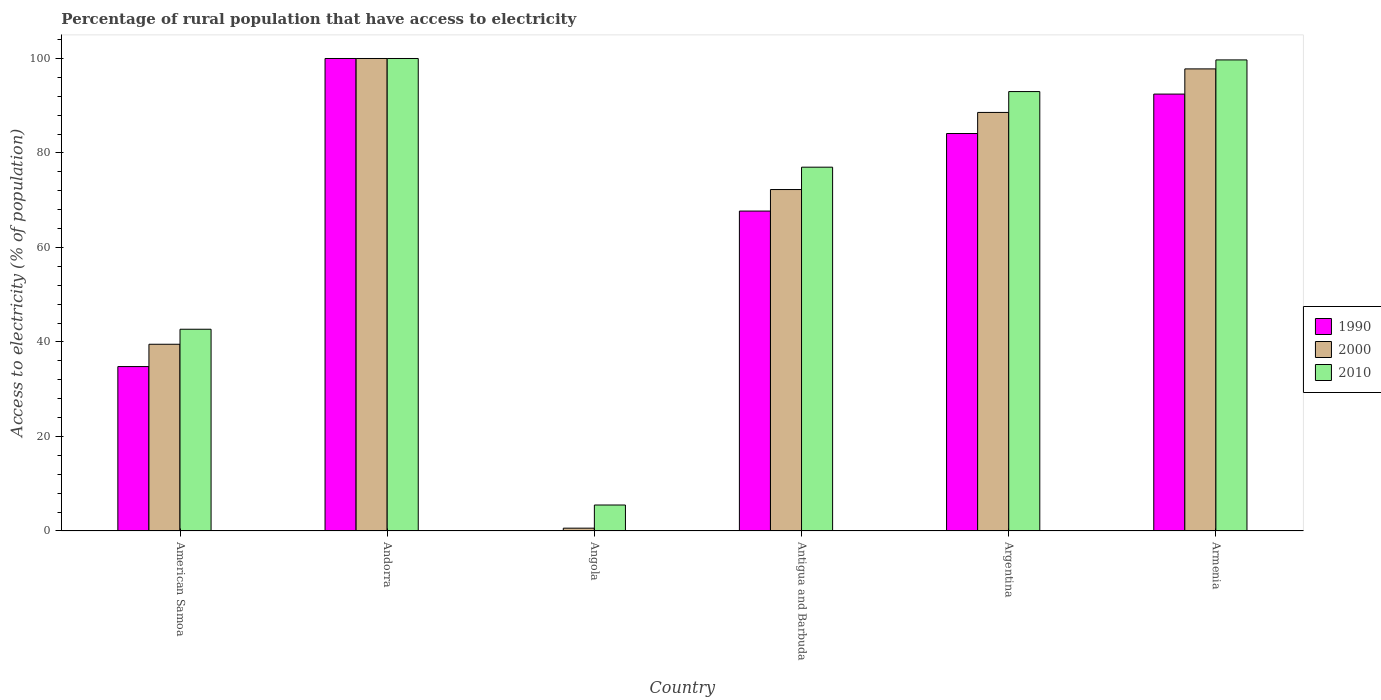How many bars are there on the 6th tick from the right?
Keep it short and to the point. 3. What is the label of the 3rd group of bars from the left?
Provide a short and direct response. Angola. In how many cases, is the number of bars for a given country not equal to the number of legend labels?
Provide a succinct answer. 0. What is the percentage of rural population that have access to electricity in 1990 in Armenia?
Ensure brevity in your answer.  92.47. In which country was the percentage of rural population that have access to electricity in 2000 maximum?
Ensure brevity in your answer.  Andorra. In which country was the percentage of rural population that have access to electricity in 2010 minimum?
Ensure brevity in your answer.  Angola. What is the total percentage of rural population that have access to electricity in 2010 in the graph?
Your answer should be compact. 417.9. What is the difference between the percentage of rural population that have access to electricity in 2000 in Antigua and Barbuda and that in Argentina?
Make the answer very short. -16.32. What is the average percentage of rural population that have access to electricity in 2010 per country?
Ensure brevity in your answer.  69.65. What is the difference between the percentage of rural population that have access to electricity of/in 2010 and percentage of rural population that have access to electricity of/in 1990 in Antigua and Barbuda?
Your answer should be very brief. 9.29. What is the ratio of the percentage of rural population that have access to electricity in 2010 in Angola to that in Argentina?
Offer a very short reply. 0.06. Is the difference between the percentage of rural population that have access to electricity in 2010 in Argentina and Armenia greater than the difference between the percentage of rural population that have access to electricity in 1990 in Argentina and Armenia?
Provide a succinct answer. Yes. What is the difference between the highest and the second highest percentage of rural population that have access to electricity in 2000?
Offer a very short reply. -9.21. What is the difference between the highest and the lowest percentage of rural population that have access to electricity in 2000?
Give a very brief answer. 99.4. Is the sum of the percentage of rural population that have access to electricity in 2000 in American Samoa and Andorra greater than the maximum percentage of rural population that have access to electricity in 2010 across all countries?
Offer a very short reply. Yes. Is it the case that in every country, the sum of the percentage of rural population that have access to electricity in 2010 and percentage of rural population that have access to electricity in 1990 is greater than the percentage of rural population that have access to electricity in 2000?
Your answer should be compact. Yes. How many countries are there in the graph?
Ensure brevity in your answer.  6. What is the difference between two consecutive major ticks on the Y-axis?
Keep it short and to the point. 20. Are the values on the major ticks of Y-axis written in scientific E-notation?
Provide a succinct answer. No. Where does the legend appear in the graph?
Your answer should be very brief. Center right. What is the title of the graph?
Make the answer very short. Percentage of rural population that have access to electricity. What is the label or title of the X-axis?
Give a very brief answer. Country. What is the label or title of the Y-axis?
Provide a short and direct response. Access to electricity (% of population). What is the Access to electricity (% of population) of 1990 in American Samoa?
Ensure brevity in your answer.  34.8. What is the Access to electricity (% of population) of 2000 in American Samoa?
Provide a short and direct response. 39.52. What is the Access to electricity (% of population) of 2010 in American Samoa?
Your answer should be very brief. 42.7. What is the Access to electricity (% of population) of 2000 in Andorra?
Offer a very short reply. 100. What is the Access to electricity (% of population) in 2010 in Andorra?
Ensure brevity in your answer.  100. What is the Access to electricity (% of population) in 1990 in Angola?
Your answer should be compact. 0.1. What is the Access to electricity (% of population) of 1990 in Antigua and Barbuda?
Your answer should be compact. 67.71. What is the Access to electricity (% of population) in 2000 in Antigua and Barbuda?
Your answer should be very brief. 72.27. What is the Access to electricity (% of population) of 2010 in Antigua and Barbuda?
Offer a terse response. 77. What is the Access to electricity (% of population) in 1990 in Argentina?
Your response must be concise. 84.12. What is the Access to electricity (% of population) in 2000 in Argentina?
Your answer should be compact. 88.59. What is the Access to electricity (% of population) in 2010 in Argentina?
Your answer should be very brief. 93. What is the Access to electricity (% of population) of 1990 in Armenia?
Your answer should be very brief. 92.47. What is the Access to electricity (% of population) of 2000 in Armenia?
Your answer should be very brief. 97.8. What is the Access to electricity (% of population) of 2010 in Armenia?
Provide a short and direct response. 99.7. Across all countries, what is the maximum Access to electricity (% of population) in 2000?
Your answer should be compact. 100. Across all countries, what is the maximum Access to electricity (% of population) in 2010?
Provide a short and direct response. 100. Across all countries, what is the minimum Access to electricity (% of population) of 2000?
Keep it short and to the point. 0.6. What is the total Access to electricity (% of population) of 1990 in the graph?
Your response must be concise. 379.2. What is the total Access to electricity (% of population) of 2000 in the graph?
Provide a succinct answer. 398.77. What is the total Access to electricity (% of population) of 2010 in the graph?
Give a very brief answer. 417.9. What is the difference between the Access to electricity (% of population) in 1990 in American Samoa and that in Andorra?
Your answer should be compact. -65.2. What is the difference between the Access to electricity (% of population) of 2000 in American Samoa and that in Andorra?
Provide a succinct answer. -60.48. What is the difference between the Access to electricity (% of population) in 2010 in American Samoa and that in Andorra?
Offer a terse response. -57.3. What is the difference between the Access to electricity (% of population) in 1990 in American Samoa and that in Angola?
Give a very brief answer. 34.7. What is the difference between the Access to electricity (% of population) of 2000 in American Samoa and that in Angola?
Your response must be concise. 38.92. What is the difference between the Access to electricity (% of population) in 2010 in American Samoa and that in Angola?
Your answer should be compact. 37.2. What is the difference between the Access to electricity (% of population) of 1990 in American Samoa and that in Antigua and Barbuda?
Your response must be concise. -32.91. What is the difference between the Access to electricity (% of population) in 2000 in American Samoa and that in Antigua and Barbuda?
Provide a succinct answer. -32.74. What is the difference between the Access to electricity (% of population) in 2010 in American Samoa and that in Antigua and Barbuda?
Your response must be concise. -34.3. What is the difference between the Access to electricity (% of population) in 1990 in American Samoa and that in Argentina?
Give a very brief answer. -49.32. What is the difference between the Access to electricity (% of population) in 2000 in American Samoa and that in Argentina?
Your answer should be compact. -49.07. What is the difference between the Access to electricity (% of population) in 2010 in American Samoa and that in Argentina?
Your answer should be compact. -50.3. What is the difference between the Access to electricity (% of population) in 1990 in American Samoa and that in Armenia?
Your response must be concise. -57.67. What is the difference between the Access to electricity (% of population) of 2000 in American Samoa and that in Armenia?
Provide a succinct answer. -58.28. What is the difference between the Access to electricity (% of population) in 2010 in American Samoa and that in Armenia?
Make the answer very short. -57. What is the difference between the Access to electricity (% of population) in 1990 in Andorra and that in Angola?
Your answer should be very brief. 99.9. What is the difference between the Access to electricity (% of population) in 2000 in Andorra and that in Angola?
Your answer should be very brief. 99.4. What is the difference between the Access to electricity (% of population) in 2010 in Andorra and that in Angola?
Your answer should be compact. 94.5. What is the difference between the Access to electricity (% of population) of 1990 in Andorra and that in Antigua and Barbuda?
Your answer should be very brief. 32.29. What is the difference between the Access to electricity (% of population) in 2000 in Andorra and that in Antigua and Barbuda?
Provide a succinct answer. 27.73. What is the difference between the Access to electricity (% of population) of 2010 in Andorra and that in Antigua and Barbuda?
Provide a short and direct response. 23. What is the difference between the Access to electricity (% of population) in 1990 in Andorra and that in Argentina?
Make the answer very short. 15.88. What is the difference between the Access to electricity (% of population) of 2000 in Andorra and that in Argentina?
Offer a terse response. 11.41. What is the difference between the Access to electricity (% of population) of 1990 in Andorra and that in Armenia?
Provide a succinct answer. 7.53. What is the difference between the Access to electricity (% of population) in 1990 in Angola and that in Antigua and Barbuda?
Ensure brevity in your answer.  -67.61. What is the difference between the Access to electricity (% of population) in 2000 in Angola and that in Antigua and Barbuda?
Your response must be concise. -71.67. What is the difference between the Access to electricity (% of population) in 2010 in Angola and that in Antigua and Barbuda?
Make the answer very short. -71.5. What is the difference between the Access to electricity (% of population) of 1990 in Angola and that in Argentina?
Provide a short and direct response. -84.02. What is the difference between the Access to electricity (% of population) of 2000 in Angola and that in Argentina?
Offer a very short reply. -87.99. What is the difference between the Access to electricity (% of population) of 2010 in Angola and that in Argentina?
Offer a very short reply. -87.5. What is the difference between the Access to electricity (% of population) of 1990 in Angola and that in Armenia?
Offer a very short reply. -92.37. What is the difference between the Access to electricity (% of population) of 2000 in Angola and that in Armenia?
Your answer should be very brief. -97.2. What is the difference between the Access to electricity (% of population) of 2010 in Angola and that in Armenia?
Your answer should be compact. -94.2. What is the difference between the Access to electricity (% of population) in 1990 in Antigua and Barbuda and that in Argentina?
Your answer should be compact. -16.41. What is the difference between the Access to electricity (% of population) of 2000 in Antigua and Barbuda and that in Argentina?
Provide a succinct answer. -16.32. What is the difference between the Access to electricity (% of population) of 1990 in Antigua and Barbuda and that in Armenia?
Your answer should be very brief. -24.76. What is the difference between the Access to electricity (% of population) in 2000 in Antigua and Barbuda and that in Armenia?
Offer a very short reply. -25.54. What is the difference between the Access to electricity (% of population) of 2010 in Antigua and Barbuda and that in Armenia?
Offer a very short reply. -22.7. What is the difference between the Access to electricity (% of population) of 1990 in Argentina and that in Armenia?
Offer a very short reply. -8.35. What is the difference between the Access to electricity (% of population) of 2000 in Argentina and that in Armenia?
Your answer should be compact. -9.21. What is the difference between the Access to electricity (% of population) of 2010 in Argentina and that in Armenia?
Keep it short and to the point. -6.7. What is the difference between the Access to electricity (% of population) in 1990 in American Samoa and the Access to electricity (% of population) in 2000 in Andorra?
Provide a succinct answer. -65.2. What is the difference between the Access to electricity (% of population) of 1990 in American Samoa and the Access to electricity (% of population) of 2010 in Andorra?
Your response must be concise. -65.2. What is the difference between the Access to electricity (% of population) in 2000 in American Samoa and the Access to electricity (% of population) in 2010 in Andorra?
Provide a short and direct response. -60.48. What is the difference between the Access to electricity (% of population) of 1990 in American Samoa and the Access to electricity (% of population) of 2000 in Angola?
Your answer should be compact. 34.2. What is the difference between the Access to electricity (% of population) in 1990 in American Samoa and the Access to electricity (% of population) in 2010 in Angola?
Provide a short and direct response. 29.3. What is the difference between the Access to electricity (% of population) in 2000 in American Samoa and the Access to electricity (% of population) in 2010 in Angola?
Provide a short and direct response. 34.02. What is the difference between the Access to electricity (% of population) of 1990 in American Samoa and the Access to electricity (% of population) of 2000 in Antigua and Barbuda?
Offer a very short reply. -37.47. What is the difference between the Access to electricity (% of population) of 1990 in American Samoa and the Access to electricity (% of population) of 2010 in Antigua and Barbuda?
Ensure brevity in your answer.  -42.2. What is the difference between the Access to electricity (% of population) in 2000 in American Samoa and the Access to electricity (% of population) in 2010 in Antigua and Barbuda?
Your answer should be compact. -37.48. What is the difference between the Access to electricity (% of population) of 1990 in American Samoa and the Access to electricity (% of population) of 2000 in Argentina?
Give a very brief answer. -53.79. What is the difference between the Access to electricity (% of population) in 1990 in American Samoa and the Access to electricity (% of population) in 2010 in Argentina?
Your answer should be compact. -58.2. What is the difference between the Access to electricity (% of population) in 2000 in American Samoa and the Access to electricity (% of population) in 2010 in Argentina?
Keep it short and to the point. -53.48. What is the difference between the Access to electricity (% of population) in 1990 in American Samoa and the Access to electricity (% of population) in 2000 in Armenia?
Your answer should be compact. -63. What is the difference between the Access to electricity (% of population) of 1990 in American Samoa and the Access to electricity (% of population) of 2010 in Armenia?
Give a very brief answer. -64.9. What is the difference between the Access to electricity (% of population) of 2000 in American Samoa and the Access to electricity (% of population) of 2010 in Armenia?
Your answer should be compact. -60.18. What is the difference between the Access to electricity (% of population) of 1990 in Andorra and the Access to electricity (% of population) of 2000 in Angola?
Your answer should be very brief. 99.4. What is the difference between the Access to electricity (% of population) of 1990 in Andorra and the Access to electricity (% of population) of 2010 in Angola?
Your response must be concise. 94.5. What is the difference between the Access to electricity (% of population) in 2000 in Andorra and the Access to electricity (% of population) in 2010 in Angola?
Make the answer very short. 94.5. What is the difference between the Access to electricity (% of population) in 1990 in Andorra and the Access to electricity (% of population) in 2000 in Antigua and Barbuda?
Ensure brevity in your answer.  27.73. What is the difference between the Access to electricity (% of population) in 2000 in Andorra and the Access to electricity (% of population) in 2010 in Antigua and Barbuda?
Keep it short and to the point. 23. What is the difference between the Access to electricity (% of population) of 1990 in Andorra and the Access to electricity (% of population) of 2000 in Argentina?
Your response must be concise. 11.41. What is the difference between the Access to electricity (% of population) in 1990 in Andorra and the Access to electricity (% of population) in 2000 in Armenia?
Make the answer very short. 2.2. What is the difference between the Access to electricity (% of population) of 2000 in Andorra and the Access to electricity (% of population) of 2010 in Armenia?
Offer a very short reply. 0.3. What is the difference between the Access to electricity (% of population) in 1990 in Angola and the Access to electricity (% of population) in 2000 in Antigua and Barbuda?
Make the answer very short. -72.17. What is the difference between the Access to electricity (% of population) of 1990 in Angola and the Access to electricity (% of population) of 2010 in Antigua and Barbuda?
Ensure brevity in your answer.  -76.9. What is the difference between the Access to electricity (% of population) in 2000 in Angola and the Access to electricity (% of population) in 2010 in Antigua and Barbuda?
Ensure brevity in your answer.  -76.4. What is the difference between the Access to electricity (% of population) in 1990 in Angola and the Access to electricity (% of population) in 2000 in Argentina?
Ensure brevity in your answer.  -88.49. What is the difference between the Access to electricity (% of population) of 1990 in Angola and the Access to electricity (% of population) of 2010 in Argentina?
Your response must be concise. -92.9. What is the difference between the Access to electricity (% of population) of 2000 in Angola and the Access to electricity (% of population) of 2010 in Argentina?
Give a very brief answer. -92.4. What is the difference between the Access to electricity (% of population) in 1990 in Angola and the Access to electricity (% of population) in 2000 in Armenia?
Offer a terse response. -97.7. What is the difference between the Access to electricity (% of population) of 1990 in Angola and the Access to electricity (% of population) of 2010 in Armenia?
Offer a terse response. -99.6. What is the difference between the Access to electricity (% of population) of 2000 in Angola and the Access to electricity (% of population) of 2010 in Armenia?
Offer a very short reply. -99.1. What is the difference between the Access to electricity (% of population) of 1990 in Antigua and Barbuda and the Access to electricity (% of population) of 2000 in Argentina?
Give a very brief answer. -20.88. What is the difference between the Access to electricity (% of population) of 1990 in Antigua and Barbuda and the Access to electricity (% of population) of 2010 in Argentina?
Your answer should be very brief. -25.29. What is the difference between the Access to electricity (% of population) in 2000 in Antigua and Barbuda and the Access to electricity (% of population) in 2010 in Argentina?
Your answer should be compact. -20.73. What is the difference between the Access to electricity (% of population) in 1990 in Antigua and Barbuda and the Access to electricity (% of population) in 2000 in Armenia?
Offer a very short reply. -30.09. What is the difference between the Access to electricity (% of population) in 1990 in Antigua and Barbuda and the Access to electricity (% of population) in 2010 in Armenia?
Make the answer very short. -31.99. What is the difference between the Access to electricity (% of population) in 2000 in Antigua and Barbuda and the Access to electricity (% of population) in 2010 in Armenia?
Offer a terse response. -27.43. What is the difference between the Access to electricity (% of population) in 1990 in Argentina and the Access to electricity (% of population) in 2000 in Armenia?
Provide a succinct answer. -13.68. What is the difference between the Access to electricity (% of population) of 1990 in Argentina and the Access to electricity (% of population) of 2010 in Armenia?
Keep it short and to the point. -15.58. What is the difference between the Access to electricity (% of population) of 2000 in Argentina and the Access to electricity (% of population) of 2010 in Armenia?
Offer a terse response. -11.11. What is the average Access to electricity (% of population) in 1990 per country?
Keep it short and to the point. 63.2. What is the average Access to electricity (% of population) of 2000 per country?
Give a very brief answer. 66.46. What is the average Access to electricity (% of population) of 2010 per country?
Give a very brief answer. 69.65. What is the difference between the Access to electricity (% of population) in 1990 and Access to electricity (% of population) in 2000 in American Samoa?
Give a very brief answer. -4.72. What is the difference between the Access to electricity (% of population) of 1990 and Access to electricity (% of population) of 2010 in American Samoa?
Your response must be concise. -7.9. What is the difference between the Access to electricity (% of population) of 2000 and Access to electricity (% of population) of 2010 in American Samoa?
Ensure brevity in your answer.  -3.18. What is the difference between the Access to electricity (% of population) of 1990 and Access to electricity (% of population) of 2010 in Andorra?
Offer a very short reply. 0. What is the difference between the Access to electricity (% of population) of 1990 and Access to electricity (% of population) of 2000 in Antigua and Barbuda?
Offer a very short reply. -4.55. What is the difference between the Access to electricity (% of population) in 1990 and Access to electricity (% of population) in 2010 in Antigua and Barbuda?
Provide a succinct answer. -9.29. What is the difference between the Access to electricity (% of population) in 2000 and Access to electricity (% of population) in 2010 in Antigua and Barbuda?
Your answer should be compact. -4.74. What is the difference between the Access to electricity (% of population) of 1990 and Access to electricity (% of population) of 2000 in Argentina?
Your answer should be compact. -4.47. What is the difference between the Access to electricity (% of population) in 1990 and Access to electricity (% of population) in 2010 in Argentina?
Offer a terse response. -8.88. What is the difference between the Access to electricity (% of population) in 2000 and Access to electricity (% of population) in 2010 in Argentina?
Make the answer very short. -4.41. What is the difference between the Access to electricity (% of population) in 1990 and Access to electricity (% of population) in 2000 in Armenia?
Make the answer very short. -5.33. What is the difference between the Access to electricity (% of population) of 1990 and Access to electricity (% of population) of 2010 in Armenia?
Offer a terse response. -7.23. What is the difference between the Access to electricity (% of population) in 2000 and Access to electricity (% of population) in 2010 in Armenia?
Make the answer very short. -1.9. What is the ratio of the Access to electricity (% of population) in 1990 in American Samoa to that in Andorra?
Your response must be concise. 0.35. What is the ratio of the Access to electricity (% of population) in 2000 in American Samoa to that in Andorra?
Make the answer very short. 0.4. What is the ratio of the Access to electricity (% of population) in 2010 in American Samoa to that in Andorra?
Offer a terse response. 0.43. What is the ratio of the Access to electricity (% of population) in 1990 in American Samoa to that in Angola?
Your response must be concise. 347.98. What is the ratio of the Access to electricity (% of population) in 2000 in American Samoa to that in Angola?
Provide a short and direct response. 65.87. What is the ratio of the Access to electricity (% of population) of 2010 in American Samoa to that in Angola?
Provide a succinct answer. 7.76. What is the ratio of the Access to electricity (% of population) of 1990 in American Samoa to that in Antigua and Barbuda?
Give a very brief answer. 0.51. What is the ratio of the Access to electricity (% of population) of 2000 in American Samoa to that in Antigua and Barbuda?
Give a very brief answer. 0.55. What is the ratio of the Access to electricity (% of population) of 2010 in American Samoa to that in Antigua and Barbuda?
Give a very brief answer. 0.55. What is the ratio of the Access to electricity (% of population) of 1990 in American Samoa to that in Argentina?
Your response must be concise. 0.41. What is the ratio of the Access to electricity (% of population) of 2000 in American Samoa to that in Argentina?
Ensure brevity in your answer.  0.45. What is the ratio of the Access to electricity (% of population) of 2010 in American Samoa to that in Argentina?
Offer a terse response. 0.46. What is the ratio of the Access to electricity (% of population) of 1990 in American Samoa to that in Armenia?
Ensure brevity in your answer.  0.38. What is the ratio of the Access to electricity (% of population) in 2000 in American Samoa to that in Armenia?
Provide a short and direct response. 0.4. What is the ratio of the Access to electricity (% of population) of 2010 in American Samoa to that in Armenia?
Keep it short and to the point. 0.43. What is the ratio of the Access to electricity (% of population) of 1990 in Andorra to that in Angola?
Your answer should be compact. 1000. What is the ratio of the Access to electricity (% of population) of 2000 in Andorra to that in Angola?
Keep it short and to the point. 166.67. What is the ratio of the Access to electricity (% of population) in 2010 in Andorra to that in Angola?
Keep it short and to the point. 18.18. What is the ratio of the Access to electricity (% of population) of 1990 in Andorra to that in Antigua and Barbuda?
Make the answer very short. 1.48. What is the ratio of the Access to electricity (% of population) of 2000 in Andorra to that in Antigua and Barbuda?
Keep it short and to the point. 1.38. What is the ratio of the Access to electricity (% of population) of 2010 in Andorra to that in Antigua and Barbuda?
Provide a succinct answer. 1.3. What is the ratio of the Access to electricity (% of population) of 1990 in Andorra to that in Argentina?
Offer a very short reply. 1.19. What is the ratio of the Access to electricity (% of population) in 2000 in Andorra to that in Argentina?
Offer a terse response. 1.13. What is the ratio of the Access to electricity (% of population) of 2010 in Andorra to that in Argentina?
Give a very brief answer. 1.08. What is the ratio of the Access to electricity (% of population) in 1990 in Andorra to that in Armenia?
Your response must be concise. 1.08. What is the ratio of the Access to electricity (% of population) in 2000 in Andorra to that in Armenia?
Offer a very short reply. 1.02. What is the ratio of the Access to electricity (% of population) of 1990 in Angola to that in Antigua and Barbuda?
Provide a succinct answer. 0. What is the ratio of the Access to electricity (% of population) in 2000 in Angola to that in Antigua and Barbuda?
Provide a succinct answer. 0.01. What is the ratio of the Access to electricity (% of population) of 2010 in Angola to that in Antigua and Barbuda?
Give a very brief answer. 0.07. What is the ratio of the Access to electricity (% of population) in 1990 in Angola to that in Argentina?
Ensure brevity in your answer.  0. What is the ratio of the Access to electricity (% of population) of 2000 in Angola to that in Argentina?
Your response must be concise. 0.01. What is the ratio of the Access to electricity (% of population) in 2010 in Angola to that in Argentina?
Make the answer very short. 0.06. What is the ratio of the Access to electricity (% of population) of 1990 in Angola to that in Armenia?
Provide a succinct answer. 0. What is the ratio of the Access to electricity (% of population) in 2000 in Angola to that in Armenia?
Make the answer very short. 0.01. What is the ratio of the Access to electricity (% of population) of 2010 in Angola to that in Armenia?
Keep it short and to the point. 0.06. What is the ratio of the Access to electricity (% of population) in 1990 in Antigua and Barbuda to that in Argentina?
Offer a very short reply. 0.8. What is the ratio of the Access to electricity (% of population) in 2000 in Antigua and Barbuda to that in Argentina?
Provide a succinct answer. 0.82. What is the ratio of the Access to electricity (% of population) of 2010 in Antigua and Barbuda to that in Argentina?
Offer a terse response. 0.83. What is the ratio of the Access to electricity (% of population) in 1990 in Antigua and Barbuda to that in Armenia?
Offer a terse response. 0.73. What is the ratio of the Access to electricity (% of population) of 2000 in Antigua and Barbuda to that in Armenia?
Offer a very short reply. 0.74. What is the ratio of the Access to electricity (% of population) in 2010 in Antigua and Barbuda to that in Armenia?
Ensure brevity in your answer.  0.77. What is the ratio of the Access to electricity (% of population) of 1990 in Argentina to that in Armenia?
Provide a succinct answer. 0.91. What is the ratio of the Access to electricity (% of population) in 2000 in Argentina to that in Armenia?
Offer a terse response. 0.91. What is the ratio of the Access to electricity (% of population) of 2010 in Argentina to that in Armenia?
Offer a terse response. 0.93. What is the difference between the highest and the second highest Access to electricity (% of population) of 1990?
Provide a short and direct response. 7.53. What is the difference between the highest and the second highest Access to electricity (% of population) in 2010?
Ensure brevity in your answer.  0.3. What is the difference between the highest and the lowest Access to electricity (% of population) of 1990?
Offer a terse response. 99.9. What is the difference between the highest and the lowest Access to electricity (% of population) in 2000?
Keep it short and to the point. 99.4. What is the difference between the highest and the lowest Access to electricity (% of population) in 2010?
Provide a succinct answer. 94.5. 